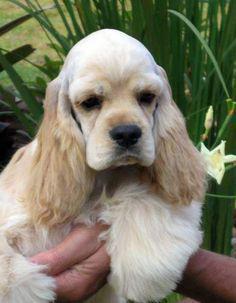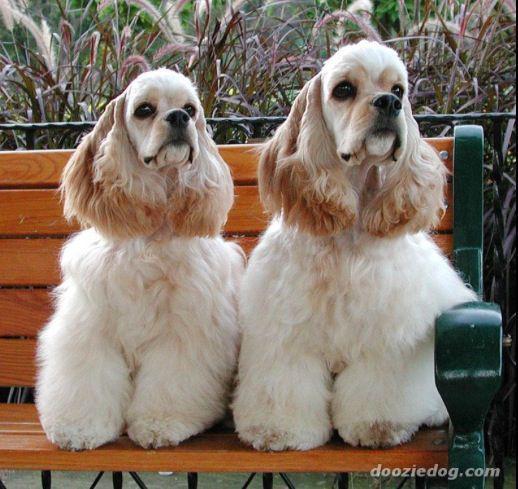The first image is the image on the left, the second image is the image on the right. Evaluate the accuracy of this statement regarding the images: "In one of the two images the dog is being held in someone's hands.". Is it true? Answer yes or no. Yes. The first image is the image on the left, the second image is the image on the right. For the images displayed, is the sentence "A hand is holding one spaniel in the left image, while the right image shows at least one spaniel sitting upright." factually correct? Answer yes or no. Yes. 